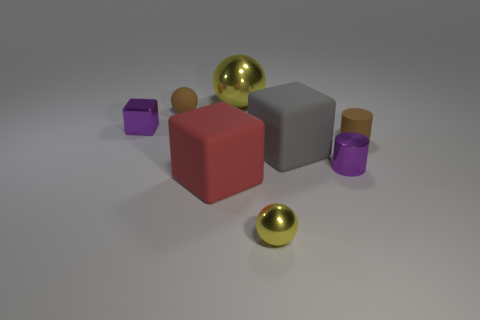Is the size of the gray matte cube the same as the red block?
Provide a short and direct response. Yes. What number of objects are large blocks that are on the right side of the red thing or large blocks on the right side of the red cube?
Your answer should be very brief. 1. There is a cylinder that is in front of the brown cylinder; is it the same color as the metallic object left of the big metal thing?
Provide a succinct answer. Yes. What number of shiny things are either large blocks or blocks?
Your answer should be compact. 1. Are there any other things that are the same size as the gray rubber block?
Keep it short and to the point. Yes. What shape is the small purple metallic thing that is on the left side of the brown matte sphere behind the purple cylinder?
Ensure brevity in your answer.  Cube. Are the small sphere that is to the left of the big yellow thing and the yellow object in front of the matte ball made of the same material?
Provide a short and direct response. No. What number of tiny yellow shiny things are behind the rubber cube right of the tiny shiny sphere?
Provide a succinct answer. 0. Do the yellow thing that is in front of the large metallic sphere and the brown object that is behind the tiny cube have the same shape?
Your response must be concise. Yes. There is a shiny thing that is both in front of the small rubber ball and on the left side of the small yellow object; what size is it?
Keep it short and to the point. Small. 